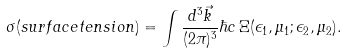Convert formula to latex. <formula><loc_0><loc_0><loc_500><loc_500>\sigma ( s u r f a c e t e n s i o n ) = \int { \frac { d ^ { 3 } \vec { k } } { ( 2 \pi ) ^ { 3 } } } \hbar { c } \, \Xi ( \epsilon _ { 1 } , \mu _ { 1 } ; \epsilon _ { 2 } , \mu _ { 2 } ) .</formula> 